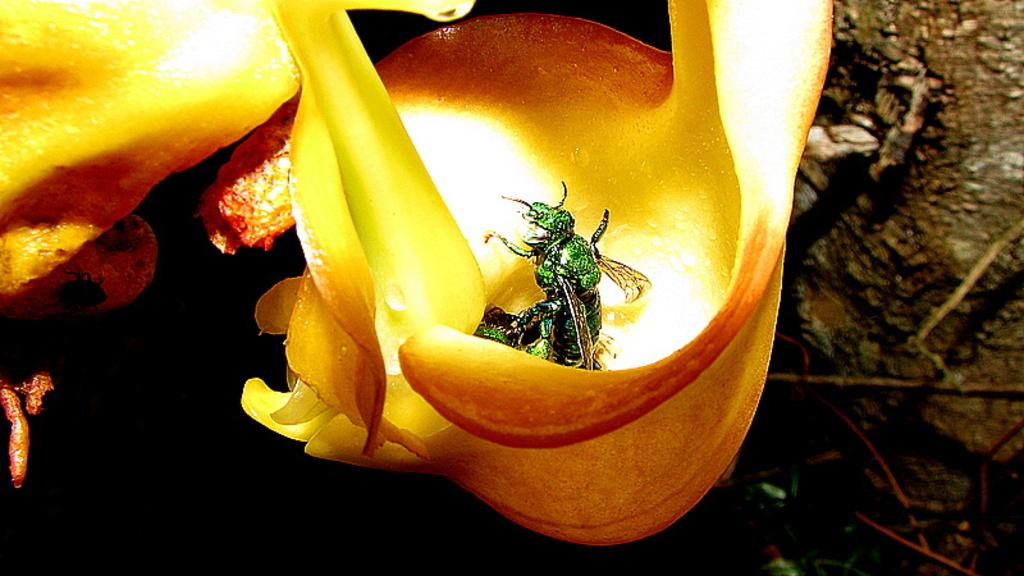What is present on the yellow flower in the image? There is an insect on the yellow flower in the image. What is the color of the flower that the insect is on? The flower is yellow. What can be observed in the background of the image? The background of the image is dark in color. What type of canvas is the insect using to transport the tray in the image? There is no canvas or tray present in the image; it features an insect on a yellow flower with a dark background. 